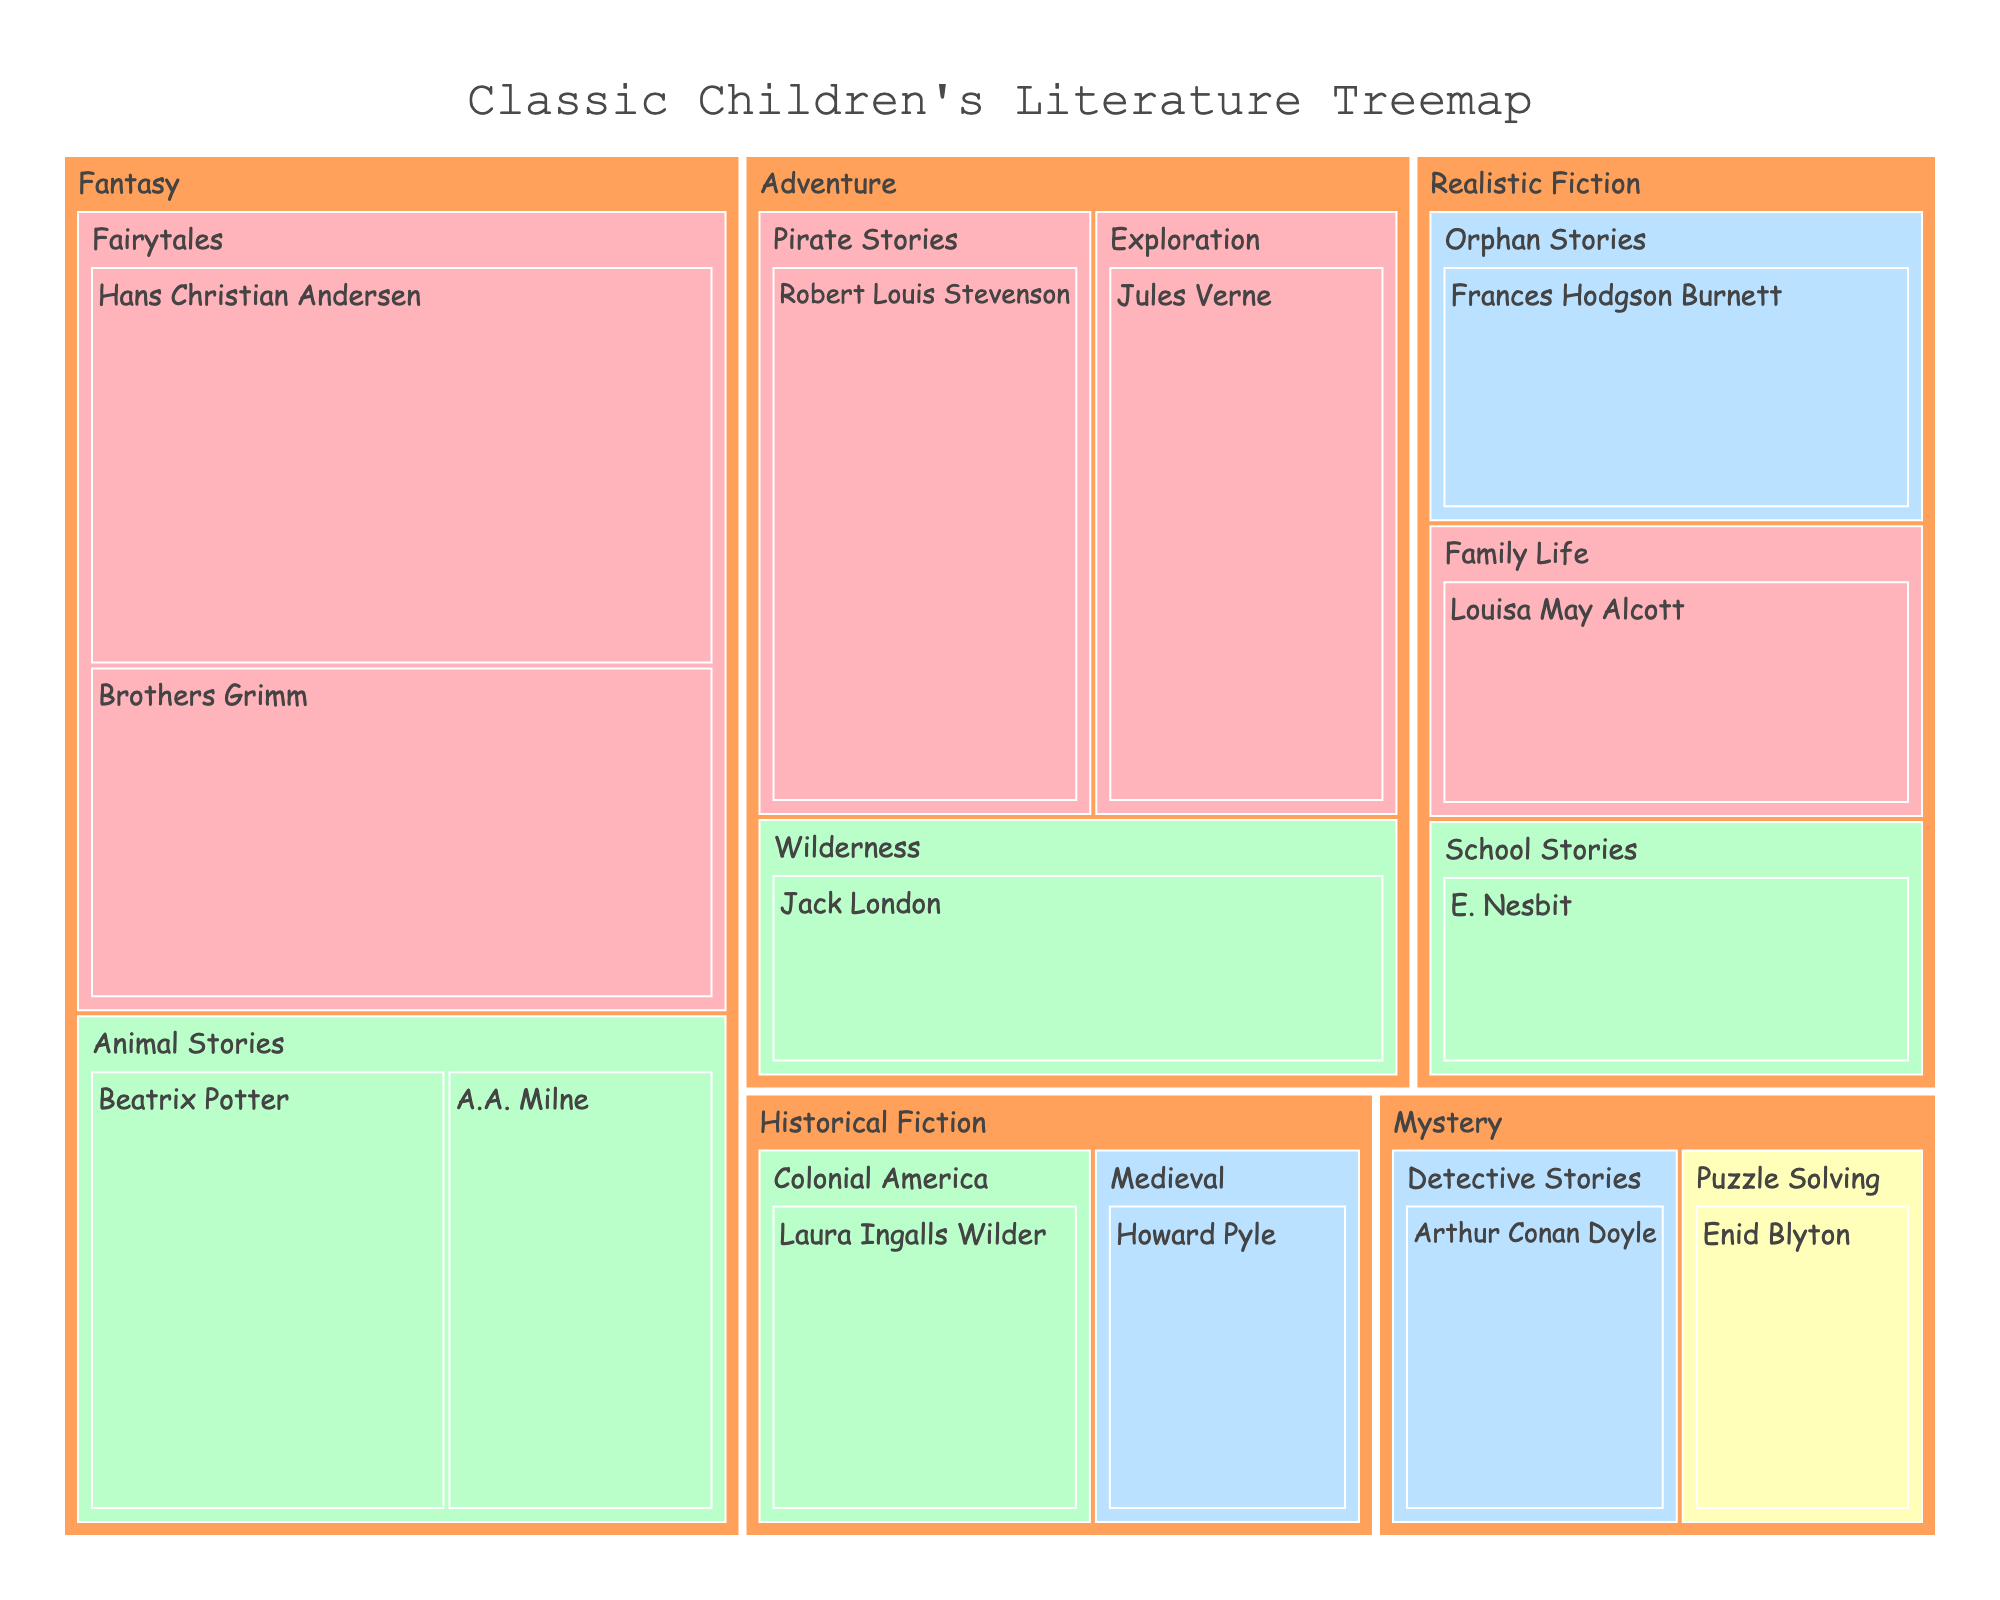What is the title of the figure? The title is usually placed at the top of the figure and is meant to provide a brief description of what the figure is about. Looking at the top of the figure, the title reads "Classic Children's Literature Treemap"
Answer: Classic Children's Literature Treemap Which genre has the highest total value? To determine which genre has the highest total value, sum up the values of all subgenres within each genre. Fantasy: (30+25+20+15)=90, Adventure: (18+22+20)=60, Realistic Fiction: (17+14+16)=47, Historical Fiction: (12+15)=27, Mystery: (13+11)=24. Fantasy has the highest total value.
Answer: Fantasy Who has the highest value in the Fairytales subgenre? Look at the subgenre Fairytales under the genre Fantasy. Compare the values for Hans Christian Andersen (30) and Brothers Grimm (25). Hans Christian Andersen has the highest value.
Answer: Hans Christian Andersen Which era is associated with the most authors in the Adventure genre? In the Adventure genre, check the eras associated with the authors. Robert Louis Stevenson (19th Century), Jules Verne (19th Century), Jack London (Early 20th Century). The 19th Century has the most authors.
Answer: 19th Century What's the combined value of authors from the 19th Century? Sum up the values of all authors from the 19th Century: Hans Christian Andersen (30), Brothers Grimm (25), Robert Louis Stevenson (22), Jules Verne (20), Louisa May Alcott (16). The total is 30+25+22+20+16=113.
Answer: 113 Which subgenre under the Realistic Fiction genre has the lowest value? Look at the subgenres under Realistic Fiction. Compare the values: Orphan Stories (17), School Stories (14), Family Life (16). School Stories has the lowest value.
Answer: School Stories Which genre has the least total value? Sum up the values of each genre. Fantasy (90), Adventure (60), Realistic Fiction (47), Historical Fiction (27), Mystery (24). Mystery has the least total value.
Answer: Mystery What's the average value of the Animal Stories subgenre? The Animal Stories subgenre includes Beatrix Potter (20) and A.A. Milne (15). The average is calculated by (20+15)/2=17.5.
Answer: 17.5 Who authored books in the Detective Stories subgenre, and what is the value? Look for the subgenre Detective Stories under the Mystery genre. The author is Arthur Conan Doyle, and the value is 13.
Answer: Arthur Conan Doyle, 13 What color represents the Early 20th Century era? The Early 20th Century era is represented by the color #BAFFC9, which appears as a light green shade in the treemap.
Answer: Light green 